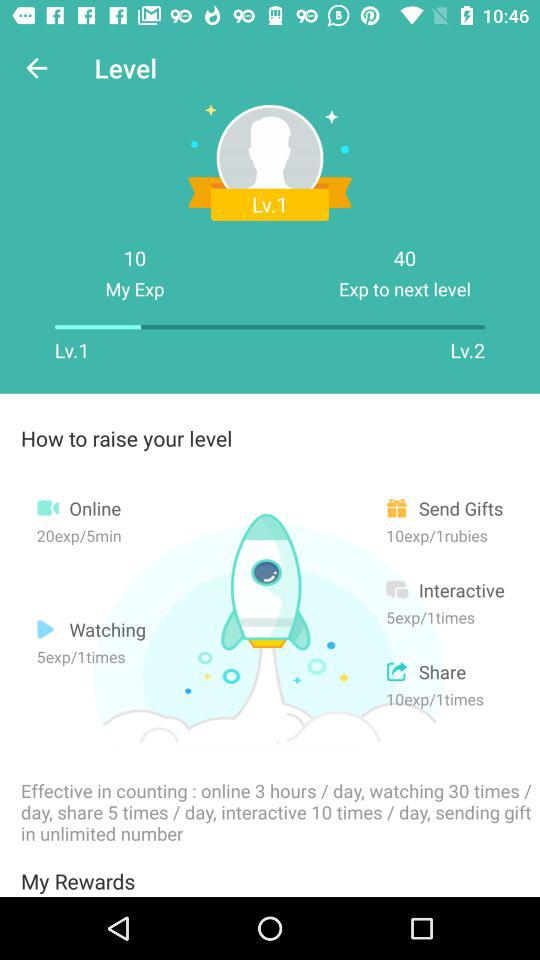How many "exp" can we share at 1 time? You can share 10 "exp" at 1 time. 